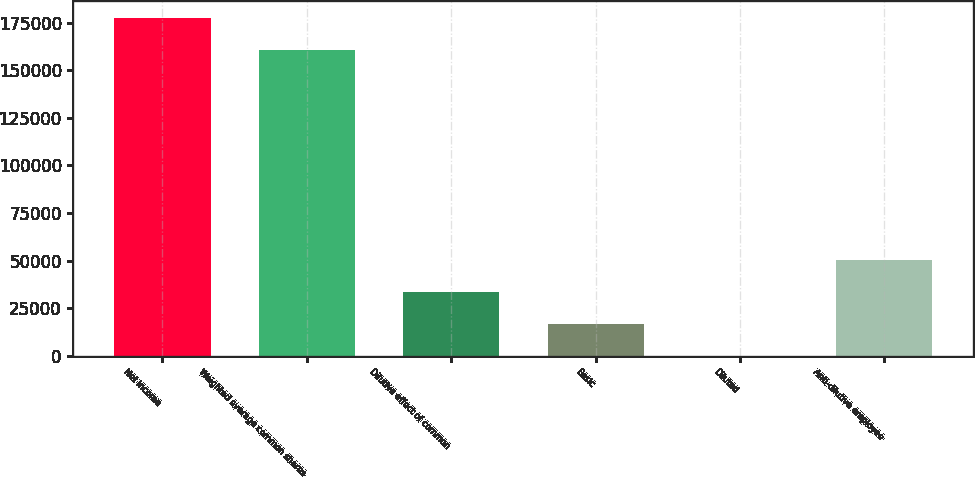Convert chart. <chart><loc_0><loc_0><loc_500><loc_500><bar_chart><fcel>Net income<fcel>Weighted average common shares<fcel>Dilutive effect of common<fcel>Basic<fcel>Diluted<fcel>Anti-dilutive employee<nl><fcel>177288<fcel>160520<fcel>33537.1<fcel>16769.1<fcel>1.15<fcel>50305.1<nl></chart> 